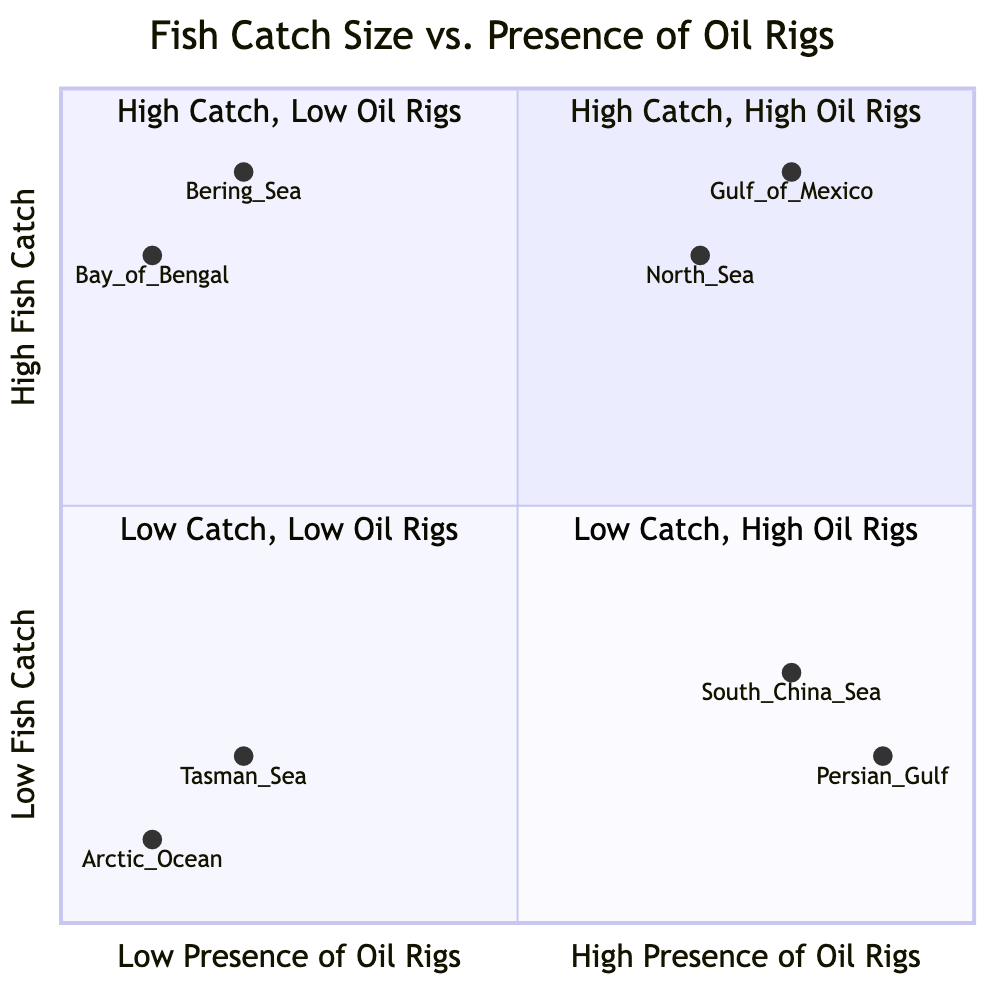What are the key areas in the quadrant with high fish catch and high presence of oil rigs? The quadrant for high fish catch and high presence of oil rigs includes the Gulf of Mexico and North Sea. These areas are characterized by rich biodiversity and high fish biomass.
Answer: Gulf of Mexico, North Sea Which quadrant contains the Bay of Bengal? The Bay of Bengal is located in the quadrant for high fish catch and low presence of oil rigs, indicating that it has a natural abundance of fish with minimal industrial disruption.
Answer: High Catch, Low Oil Rigs How many key areas are listed in the quadrant with low fish catch and low presence of oil rigs? The quadrant with low fish catch and low presence of oil rigs includes two key areas: Arctic Ocean and Tasman Sea. Therefore, there are two key areas in this quadrant.
Answer: 2 What characteristics do areas in the quadrant with low fish catch and high presence of oil rigs share? Areas with low fish catch and high presence of oil rigs, like the Persian Gulf and South China Sea, share characteristics such as reduced fish populations and potential pollution affecting habitats. This indicates the negative impact of oil rigs on fish populations.
Answer: Reduced fish populations, potential pollution Which area has the highest fish catch presence among the listed locations? The Gulf of Mexico has the highest presence of fish catch among the listed areas, as it falls into the category of high fish catch and high presence of oil rigs.
Answer: Gulf of Mexico In the quadrant with low fish catch and low presence of oil rigs, which area is found farthest north? The Arctic Ocean is located in the quadrant with low fish catch and low presence of oil rigs, and it is positioned farthest north compared to the Tasman Sea.
Answer: Arctic Ocean What is the catch size presence of the Persian Gulf? The Persian Gulf falls into the quadrant with low fish catch and high presence of oil rigs, indicating a low level of fish catch.
Answer: Low fish catch Which area is characterized by minimal industrial disruption and is classified as a high fish catch area? The Bering Sea is classified as a high fish catch area with minimal industrial disruption, signifying a natural abundance conducive to sustainable fishing practices.
Answer: Bering Sea 